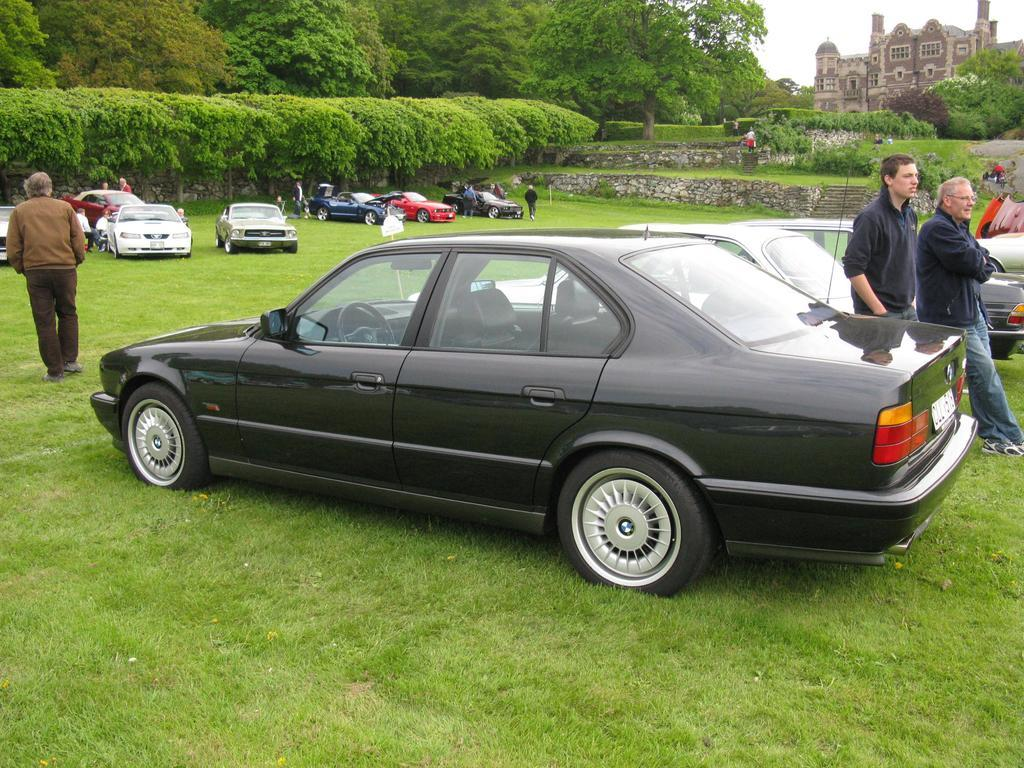What can be seen in the background of the image? There is a building and the sky visible in the background of the image. What type of natural environment is present in the image? Trees and green grass are present in the image. What types of man-made objects can be seen in the image? Vehicles are visible in the image. Are there any living beings in the image? Yes, people are present in the image. What else can be found in the image besides the mentioned elements? There are objects in the image. Can you see the cook performing magic tricks with the crushed ice in the image? There is no cook, magic tricks, or crushed ice present in the image. 